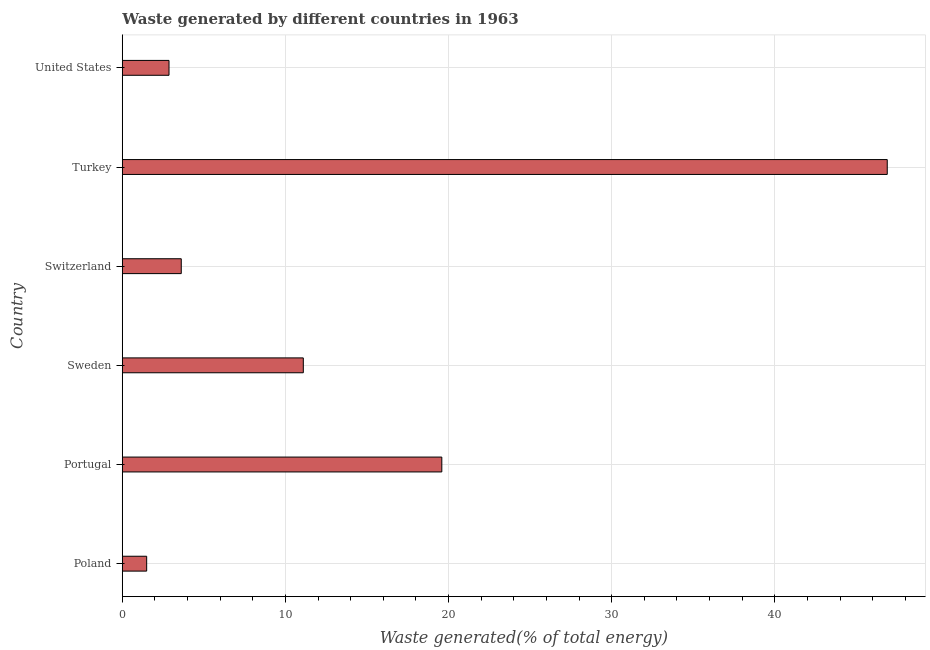What is the title of the graph?
Offer a terse response. Waste generated by different countries in 1963. What is the label or title of the X-axis?
Offer a very short reply. Waste generated(% of total energy). What is the label or title of the Y-axis?
Offer a very short reply. Country. What is the amount of waste generated in Turkey?
Give a very brief answer. 46.89. Across all countries, what is the maximum amount of waste generated?
Ensure brevity in your answer.  46.89. Across all countries, what is the minimum amount of waste generated?
Provide a succinct answer. 1.49. In which country was the amount of waste generated maximum?
Offer a terse response. Turkey. What is the sum of the amount of waste generated?
Keep it short and to the point. 85.55. What is the difference between the amount of waste generated in Poland and Sweden?
Your answer should be compact. -9.6. What is the average amount of waste generated per country?
Give a very brief answer. 14.26. What is the median amount of waste generated?
Provide a short and direct response. 7.36. In how many countries, is the amount of waste generated greater than 20 %?
Provide a short and direct response. 1. What is the ratio of the amount of waste generated in Sweden to that in Turkey?
Your answer should be very brief. 0.24. Is the amount of waste generated in Portugal less than that in Turkey?
Your answer should be compact. Yes. Is the difference between the amount of waste generated in Switzerland and Turkey greater than the difference between any two countries?
Keep it short and to the point. No. What is the difference between the highest and the second highest amount of waste generated?
Make the answer very short. 27.31. What is the difference between the highest and the lowest amount of waste generated?
Give a very brief answer. 45.4. In how many countries, is the amount of waste generated greater than the average amount of waste generated taken over all countries?
Provide a succinct answer. 2. How many countries are there in the graph?
Provide a succinct answer. 6. What is the difference between two consecutive major ticks on the X-axis?
Give a very brief answer. 10. What is the Waste generated(% of total energy) in Poland?
Your response must be concise. 1.49. What is the Waste generated(% of total energy) in Portugal?
Offer a terse response. 19.59. What is the Waste generated(% of total energy) in Sweden?
Give a very brief answer. 11.1. What is the Waste generated(% of total energy) of Switzerland?
Provide a short and direct response. 3.62. What is the Waste generated(% of total energy) in Turkey?
Keep it short and to the point. 46.89. What is the Waste generated(% of total energy) of United States?
Offer a very short reply. 2.86. What is the difference between the Waste generated(% of total energy) in Poland and Portugal?
Your response must be concise. -18.09. What is the difference between the Waste generated(% of total energy) in Poland and Sweden?
Ensure brevity in your answer.  -9.6. What is the difference between the Waste generated(% of total energy) in Poland and Switzerland?
Your answer should be very brief. -2.12. What is the difference between the Waste generated(% of total energy) in Poland and Turkey?
Provide a short and direct response. -45.4. What is the difference between the Waste generated(% of total energy) in Poland and United States?
Ensure brevity in your answer.  -1.37. What is the difference between the Waste generated(% of total energy) in Portugal and Sweden?
Offer a terse response. 8.49. What is the difference between the Waste generated(% of total energy) in Portugal and Switzerland?
Your answer should be very brief. 15.97. What is the difference between the Waste generated(% of total energy) in Portugal and Turkey?
Keep it short and to the point. -27.31. What is the difference between the Waste generated(% of total energy) in Portugal and United States?
Keep it short and to the point. 16.72. What is the difference between the Waste generated(% of total energy) in Sweden and Switzerland?
Your answer should be very brief. 7.48. What is the difference between the Waste generated(% of total energy) in Sweden and Turkey?
Your answer should be very brief. -35.8. What is the difference between the Waste generated(% of total energy) in Sweden and United States?
Offer a terse response. 8.23. What is the difference between the Waste generated(% of total energy) in Switzerland and Turkey?
Provide a succinct answer. -43.28. What is the difference between the Waste generated(% of total energy) in Switzerland and United States?
Keep it short and to the point. 0.75. What is the difference between the Waste generated(% of total energy) in Turkey and United States?
Your response must be concise. 44.03. What is the ratio of the Waste generated(% of total energy) in Poland to that in Portugal?
Keep it short and to the point. 0.08. What is the ratio of the Waste generated(% of total energy) in Poland to that in Sweden?
Keep it short and to the point. 0.14. What is the ratio of the Waste generated(% of total energy) in Poland to that in Switzerland?
Provide a succinct answer. 0.41. What is the ratio of the Waste generated(% of total energy) in Poland to that in Turkey?
Provide a succinct answer. 0.03. What is the ratio of the Waste generated(% of total energy) in Poland to that in United States?
Make the answer very short. 0.52. What is the ratio of the Waste generated(% of total energy) in Portugal to that in Sweden?
Your answer should be very brief. 1.76. What is the ratio of the Waste generated(% of total energy) in Portugal to that in Switzerland?
Provide a succinct answer. 5.42. What is the ratio of the Waste generated(% of total energy) in Portugal to that in Turkey?
Offer a terse response. 0.42. What is the ratio of the Waste generated(% of total energy) in Portugal to that in United States?
Offer a terse response. 6.84. What is the ratio of the Waste generated(% of total energy) in Sweden to that in Switzerland?
Keep it short and to the point. 3.07. What is the ratio of the Waste generated(% of total energy) in Sweden to that in Turkey?
Give a very brief answer. 0.24. What is the ratio of the Waste generated(% of total energy) in Sweden to that in United States?
Keep it short and to the point. 3.87. What is the ratio of the Waste generated(% of total energy) in Switzerland to that in Turkey?
Provide a short and direct response. 0.08. What is the ratio of the Waste generated(% of total energy) in Switzerland to that in United States?
Provide a short and direct response. 1.26. What is the ratio of the Waste generated(% of total energy) in Turkey to that in United States?
Your answer should be compact. 16.37. 